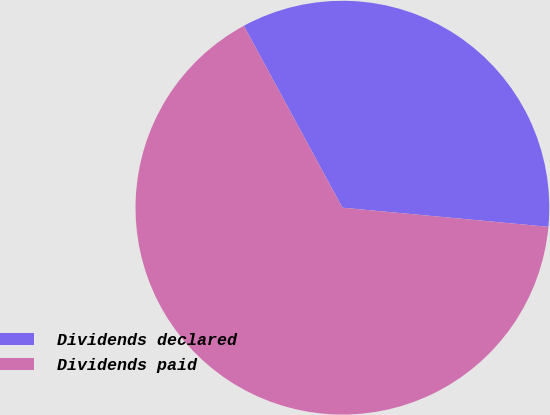Convert chart to OTSL. <chart><loc_0><loc_0><loc_500><loc_500><pie_chart><fcel>Dividends declared<fcel>Dividends paid<nl><fcel>34.38%<fcel>65.62%<nl></chart> 